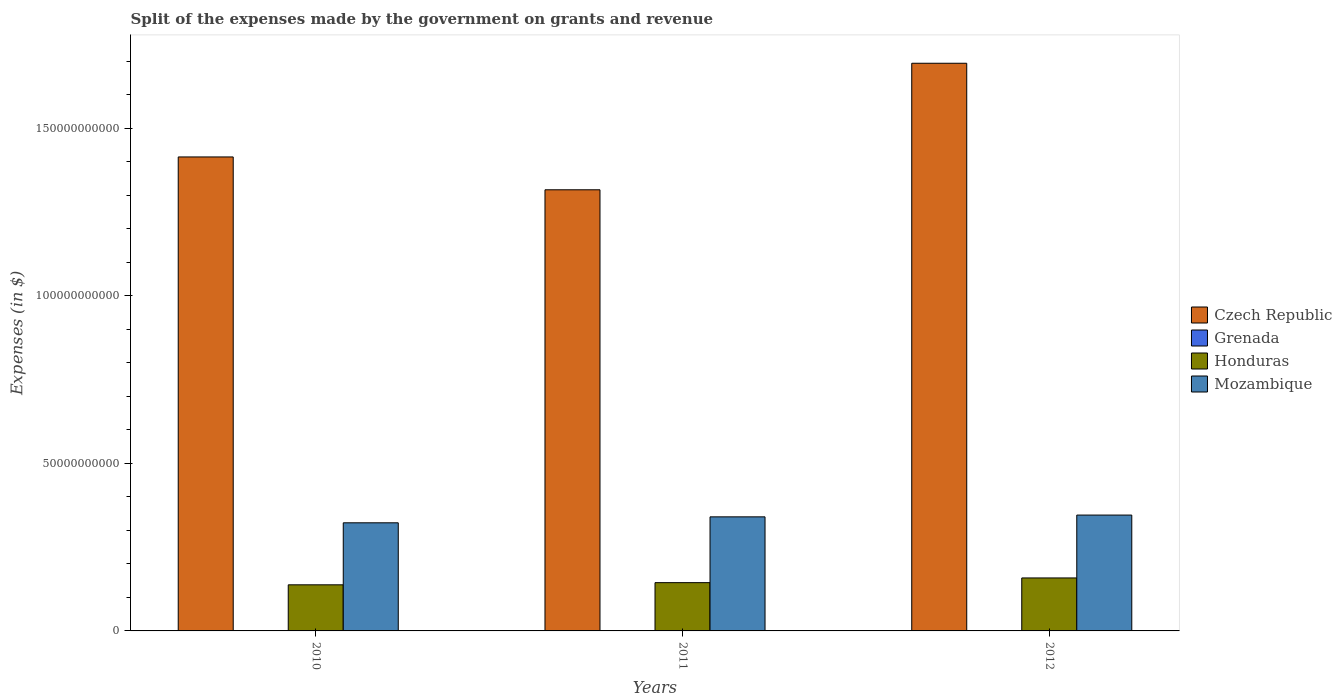Are the number of bars per tick equal to the number of legend labels?
Offer a very short reply. Yes. What is the label of the 3rd group of bars from the left?
Make the answer very short. 2012. What is the expenses made by the government on grants and revenue in Grenada in 2012?
Offer a very short reply. 4.36e+07. Across all years, what is the maximum expenses made by the government on grants and revenue in Czech Republic?
Provide a short and direct response. 1.69e+11. Across all years, what is the minimum expenses made by the government on grants and revenue in Mozambique?
Offer a terse response. 3.23e+1. In which year was the expenses made by the government on grants and revenue in Grenada minimum?
Provide a short and direct response. 2012. What is the total expenses made by the government on grants and revenue in Mozambique in the graph?
Make the answer very short. 1.01e+11. What is the difference between the expenses made by the government on grants and revenue in Honduras in 2011 and that in 2012?
Provide a succinct answer. -1.40e+09. What is the difference between the expenses made by the government on grants and revenue in Czech Republic in 2010 and the expenses made by the government on grants and revenue in Grenada in 2012?
Keep it short and to the point. 1.41e+11. What is the average expenses made by the government on grants and revenue in Honduras per year?
Offer a very short reply. 1.47e+1. In the year 2010, what is the difference between the expenses made by the government on grants and revenue in Czech Republic and expenses made by the government on grants and revenue in Mozambique?
Ensure brevity in your answer.  1.09e+11. What is the ratio of the expenses made by the government on grants and revenue in Honduras in 2010 to that in 2012?
Your answer should be compact. 0.87. Is the difference between the expenses made by the government on grants and revenue in Czech Republic in 2011 and 2012 greater than the difference between the expenses made by the government on grants and revenue in Mozambique in 2011 and 2012?
Your answer should be very brief. No. What is the difference between the highest and the second highest expenses made by the government on grants and revenue in Honduras?
Provide a succinct answer. 1.40e+09. What is the difference between the highest and the lowest expenses made by the government on grants and revenue in Mozambique?
Your answer should be very brief. 2.31e+09. What does the 2nd bar from the left in 2011 represents?
Your response must be concise. Grenada. What does the 2nd bar from the right in 2011 represents?
Ensure brevity in your answer.  Honduras. How many bars are there?
Provide a succinct answer. 12. Are all the bars in the graph horizontal?
Your answer should be very brief. No. What is the difference between two consecutive major ticks on the Y-axis?
Provide a short and direct response. 5.00e+1. Does the graph contain any zero values?
Ensure brevity in your answer.  No. How many legend labels are there?
Ensure brevity in your answer.  4. How are the legend labels stacked?
Make the answer very short. Vertical. What is the title of the graph?
Offer a terse response. Split of the expenses made by the government on grants and revenue. What is the label or title of the Y-axis?
Give a very brief answer. Expenses (in $). What is the Expenses (in $) in Czech Republic in 2010?
Give a very brief answer. 1.41e+11. What is the Expenses (in $) of Grenada in 2010?
Your answer should be very brief. 7.56e+07. What is the Expenses (in $) in Honduras in 2010?
Keep it short and to the point. 1.38e+1. What is the Expenses (in $) of Mozambique in 2010?
Offer a very short reply. 3.23e+1. What is the Expenses (in $) of Czech Republic in 2011?
Keep it short and to the point. 1.32e+11. What is the Expenses (in $) of Grenada in 2011?
Ensure brevity in your answer.  8.28e+07. What is the Expenses (in $) in Honduras in 2011?
Offer a terse response. 1.44e+1. What is the Expenses (in $) in Mozambique in 2011?
Keep it short and to the point. 3.40e+1. What is the Expenses (in $) in Czech Republic in 2012?
Your response must be concise. 1.69e+11. What is the Expenses (in $) in Grenada in 2012?
Provide a short and direct response. 4.36e+07. What is the Expenses (in $) in Honduras in 2012?
Make the answer very short. 1.58e+1. What is the Expenses (in $) of Mozambique in 2012?
Your response must be concise. 3.46e+1. Across all years, what is the maximum Expenses (in $) in Czech Republic?
Give a very brief answer. 1.69e+11. Across all years, what is the maximum Expenses (in $) in Grenada?
Your answer should be very brief. 8.28e+07. Across all years, what is the maximum Expenses (in $) in Honduras?
Keep it short and to the point. 1.58e+1. Across all years, what is the maximum Expenses (in $) in Mozambique?
Make the answer very short. 3.46e+1. Across all years, what is the minimum Expenses (in $) of Czech Republic?
Offer a terse response. 1.32e+11. Across all years, what is the minimum Expenses (in $) in Grenada?
Offer a terse response. 4.36e+07. Across all years, what is the minimum Expenses (in $) in Honduras?
Your response must be concise. 1.38e+1. Across all years, what is the minimum Expenses (in $) of Mozambique?
Keep it short and to the point. 3.23e+1. What is the total Expenses (in $) in Czech Republic in the graph?
Offer a very short reply. 4.42e+11. What is the total Expenses (in $) of Grenada in the graph?
Provide a short and direct response. 2.02e+08. What is the total Expenses (in $) of Honduras in the graph?
Your answer should be very brief. 4.40e+1. What is the total Expenses (in $) in Mozambique in the graph?
Keep it short and to the point. 1.01e+11. What is the difference between the Expenses (in $) in Czech Republic in 2010 and that in 2011?
Give a very brief answer. 9.80e+09. What is the difference between the Expenses (in $) of Grenada in 2010 and that in 2011?
Your response must be concise. -7.20e+06. What is the difference between the Expenses (in $) in Honduras in 2010 and that in 2011?
Provide a short and direct response. -6.45e+08. What is the difference between the Expenses (in $) of Mozambique in 2010 and that in 2011?
Provide a succinct answer. -1.77e+09. What is the difference between the Expenses (in $) in Czech Republic in 2010 and that in 2012?
Your answer should be very brief. -2.80e+1. What is the difference between the Expenses (in $) of Grenada in 2010 and that in 2012?
Give a very brief answer. 3.20e+07. What is the difference between the Expenses (in $) in Honduras in 2010 and that in 2012?
Make the answer very short. -2.05e+09. What is the difference between the Expenses (in $) in Mozambique in 2010 and that in 2012?
Provide a succinct answer. -2.31e+09. What is the difference between the Expenses (in $) of Czech Republic in 2011 and that in 2012?
Provide a short and direct response. -3.78e+1. What is the difference between the Expenses (in $) of Grenada in 2011 and that in 2012?
Your answer should be compact. 3.92e+07. What is the difference between the Expenses (in $) of Honduras in 2011 and that in 2012?
Make the answer very short. -1.40e+09. What is the difference between the Expenses (in $) of Mozambique in 2011 and that in 2012?
Your answer should be compact. -5.32e+08. What is the difference between the Expenses (in $) of Czech Republic in 2010 and the Expenses (in $) of Grenada in 2011?
Your response must be concise. 1.41e+11. What is the difference between the Expenses (in $) in Czech Republic in 2010 and the Expenses (in $) in Honduras in 2011?
Offer a terse response. 1.27e+11. What is the difference between the Expenses (in $) of Czech Republic in 2010 and the Expenses (in $) of Mozambique in 2011?
Give a very brief answer. 1.07e+11. What is the difference between the Expenses (in $) of Grenada in 2010 and the Expenses (in $) of Honduras in 2011?
Provide a short and direct response. -1.43e+1. What is the difference between the Expenses (in $) of Grenada in 2010 and the Expenses (in $) of Mozambique in 2011?
Make the answer very short. -3.40e+1. What is the difference between the Expenses (in $) of Honduras in 2010 and the Expenses (in $) of Mozambique in 2011?
Offer a terse response. -2.03e+1. What is the difference between the Expenses (in $) of Czech Republic in 2010 and the Expenses (in $) of Grenada in 2012?
Provide a succinct answer. 1.41e+11. What is the difference between the Expenses (in $) in Czech Republic in 2010 and the Expenses (in $) in Honduras in 2012?
Your response must be concise. 1.26e+11. What is the difference between the Expenses (in $) of Czech Republic in 2010 and the Expenses (in $) of Mozambique in 2012?
Keep it short and to the point. 1.07e+11. What is the difference between the Expenses (in $) of Grenada in 2010 and the Expenses (in $) of Honduras in 2012?
Provide a succinct answer. -1.57e+1. What is the difference between the Expenses (in $) of Grenada in 2010 and the Expenses (in $) of Mozambique in 2012?
Ensure brevity in your answer.  -3.45e+1. What is the difference between the Expenses (in $) of Honduras in 2010 and the Expenses (in $) of Mozambique in 2012?
Your answer should be very brief. -2.08e+1. What is the difference between the Expenses (in $) of Czech Republic in 2011 and the Expenses (in $) of Grenada in 2012?
Give a very brief answer. 1.32e+11. What is the difference between the Expenses (in $) of Czech Republic in 2011 and the Expenses (in $) of Honduras in 2012?
Give a very brief answer. 1.16e+11. What is the difference between the Expenses (in $) in Czech Republic in 2011 and the Expenses (in $) in Mozambique in 2012?
Offer a very short reply. 9.70e+1. What is the difference between the Expenses (in $) of Grenada in 2011 and the Expenses (in $) of Honduras in 2012?
Keep it short and to the point. -1.57e+1. What is the difference between the Expenses (in $) in Grenada in 2011 and the Expenses (in $) in Mozambique in 2012?
Give a very brief answer. -3.45e+1. What is the difference between the Expenses (in $) of Honduras in 2011 and the Expenses (in $) of Mozambique in 2012?
Your answer should be very brief. -2.02e+1. What is the average Expenses (in $) in Czech Republic per year?
Provide a short and direct response. 1.47e+11. What is the average Expenses (in $) in Grenada per year?
Offer a very short reply. 6.73e+07. What is the average Expenses (in $) in Honduras per year?
Provide a succinct answer. 1.47e+1. What is the average Expenses (in $) of Mozambique per year?
Make the answer very short. 3.36e+1. In the year 2010, what is the difference between the Expenses (in $) in Czech Republic and Expenses (in $) in Grenada?
Provide a short and direct response. 1.41e+11. In the year 2010, what is the difference between the Expenses (in $) in Czech Republic and Expenses (in $) in Honduras?
Provide a succinct answer. 1.28e+11. In the year 2010, what is the difference between the Expenses (in $) in Czech Republic and Expenses (in $) in Mozambique?
Your answer should be compact. 1.09e+11. In the year 2010, what is the difference between the Expenses (in $) in Grenada and Expenses (in $) in Honduras?
Offer a terse response. -1.37e+1. In the year 2010, what is the difference between the Expenses (in $) in Grenada and Expenses (in $) in Mozambique?
Provide a succinct answer. -3.22e+1. In the year 2010, what is the difference between the Expenses (in $) in Honduras and Expenses (in $) in Mozambique?
Keep it short and to the point. -1.85e+1. In the year 2011, what is the difference between the Expenses (in $) in Czech Republic and Expenses (in $) in Grenada?
Keep it short and to the point. 1.32e+11. In the year 2011, what is the difference between the Expenses (in $) of Czech Republic and Expenses (in $) of Honduras?
Provide a succinct answer. 1.17e+11. In the year 2011, what is the difference between the Expenses (in $) of Czech Republic and Expenses (in $) of Mozambique?
Provide a succinct answer. 9.76e+1. In the year 2011, what is the difference between the Expenses (in $) in Grenada and Expenses (in $) in Honduras?
Your response must be concise. -1.43e+1. In the year 2011, what is the difference between the Expenses (in $) of Grenada and Expenses (in $) of Mozambique?
Your answer should be very brief. -3.39e+1. In the year 2011, what is the difference between the Expenses (in $) of Honduras and Expenses (in $) of Mozambique?
Make the answer very short. -1.96e+1. In the year 2012, what is the difference between the Expenses (in $) in Czech Republic and Expenses (in $) in Grenada?
Provide a succinct answer. 1.69e+11. In the year 2012, what is the difference between the Expenses (in $) in Czech Republic and Expenses (in $) in Honduras?
Give a very brief answer. 1.54e+11. In the year 2012, what is the difference between the Expenses (in $) in Czech Republic and Expenses (in $) in Mozambique?
Give a very brief answer. 1.35e+11. In the year 2012, what is the difference between the Expenses (in $) in Grenada and Expenses (in $) in Honduras?
Your answer should be compact. -1.58e+1. In the year 2012, what is the difference between the Expenses (in $) in Grenada and Expenses (in $) in Mozambique?
Your answer should be compact. -3.45e+1. In the year 2012, what is the difference between the Expenses (in $) of Honduras and Expenses (in $) of Mozambique?
Your response must be concise. -1.88e+1. What is the ratio of the Expenses (in $) in Czech Republic in 2010 to that in 2011?
Provide a short and direct response. 1.07. What is the ratio of the Expenses (in $) of Honduras in 2010 to that in 2011?
Offer a terse response. 0.96. What is the ratio of the Expenses (in $) of Mozambique in 2010 to that in 2011?
Make the answer very short. 0.95. What is the ratio of the Expenses (in $) of Czech Republic in 2010 to that in 2012?
Your answer should be very brief. 0.83. What is the ratio of the Expenses (in $) in Grenada in 2010 to that in 2012?
Your answer should be very brief. 1.73. What is the ratio of the Expenses (in $) in Honduras in 2010 to that in 2012?
Keep it short and to the point. 0.87. What is the ratio of the Expenses (in $) in Czech Republic in 2011 to that in 2012?
Provide a short and direct response. 0.78. What is the ratio of the Expenses (in $) of Grenada in 2011 to that in 2012?
Make the answer very short. 1.9. What is the ratio of the Expenses (in $) of Honduras in 2011 to that in 2012?
Offer a terse response. 0.91. What is the ratio of the Expenses (in $) of Mozambique in 2011 to that in 2012?
Make the answer very short. 0.98. What is the difference between the highest and the second highest Expenses (in $) in Czech Republic?
Offer a very short reply. 2.80e+1. What is the difference between the highest and the second highest Expenses (in $) of Grenada?
Offer a terse response. 7.20e+06. What is the difference between the highest and the second highest Expenses (in $) in Honduras?
Provide a short and direct response. 1.40e+09. What is the difference between the highest and the second highest Expenses (in $) of Mozambique?
Provide a short and direct response. 5.32e+08. What is the difference between the highest and the lowest Expenses (in $) of Czech Republic?
Offer a terse response. 3.78e+1. What is the difference between the highest and the lowest Expenses (in $) of Grenada?
Make the answer very short. 3.92e+07. What is the difference between the highest and the lowest Expenses (in $) in Honduras?
Offer a very short reply. 2.05e+09. What is the difference between the highest and the lowest Expenses (in $) in Mozambique?
Your response must be concise. 2.31e+09. 